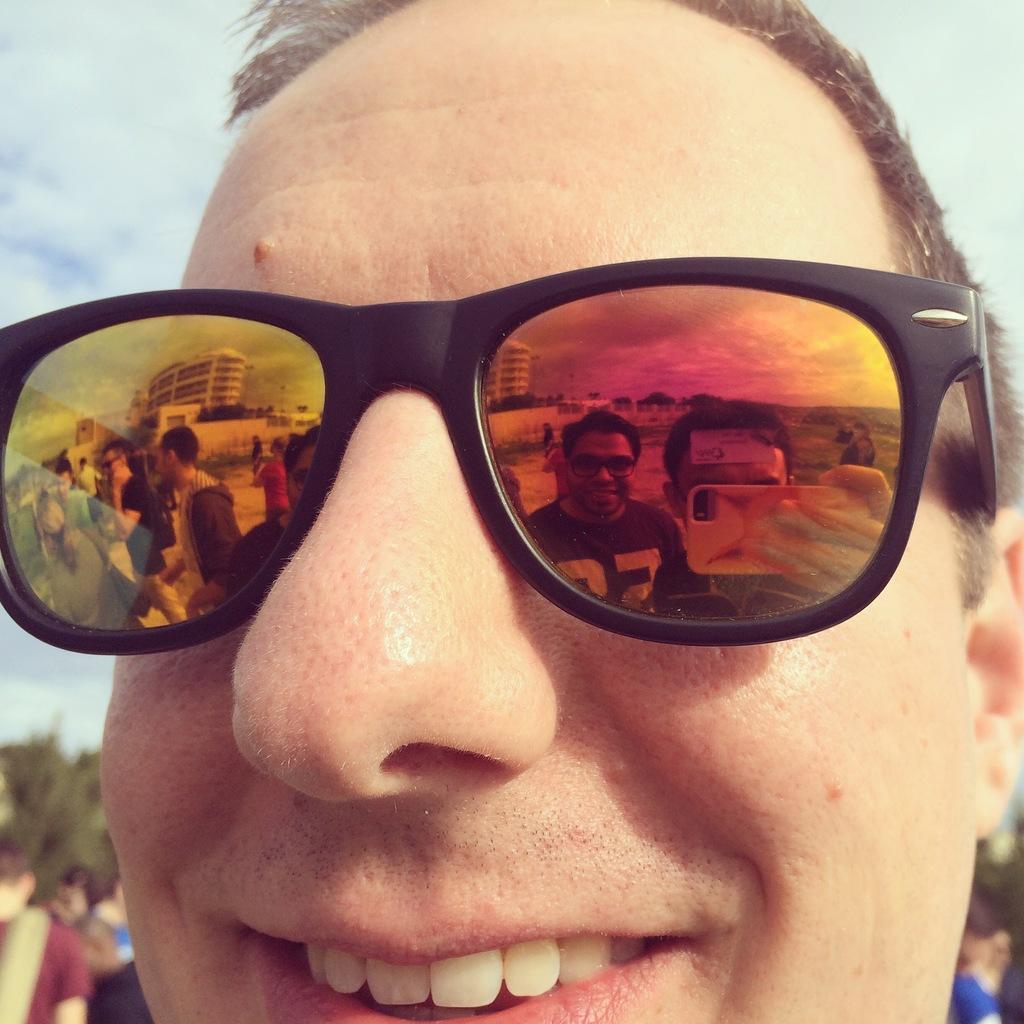Describe this image in one or two sentences. Here we can see a man face and goggles on his eyes and on the glasses we can see the reflection of people,buildings,mobile and clouds in the sky. In the background the image is blur but we can see few people,trees and clouds in the sky. 